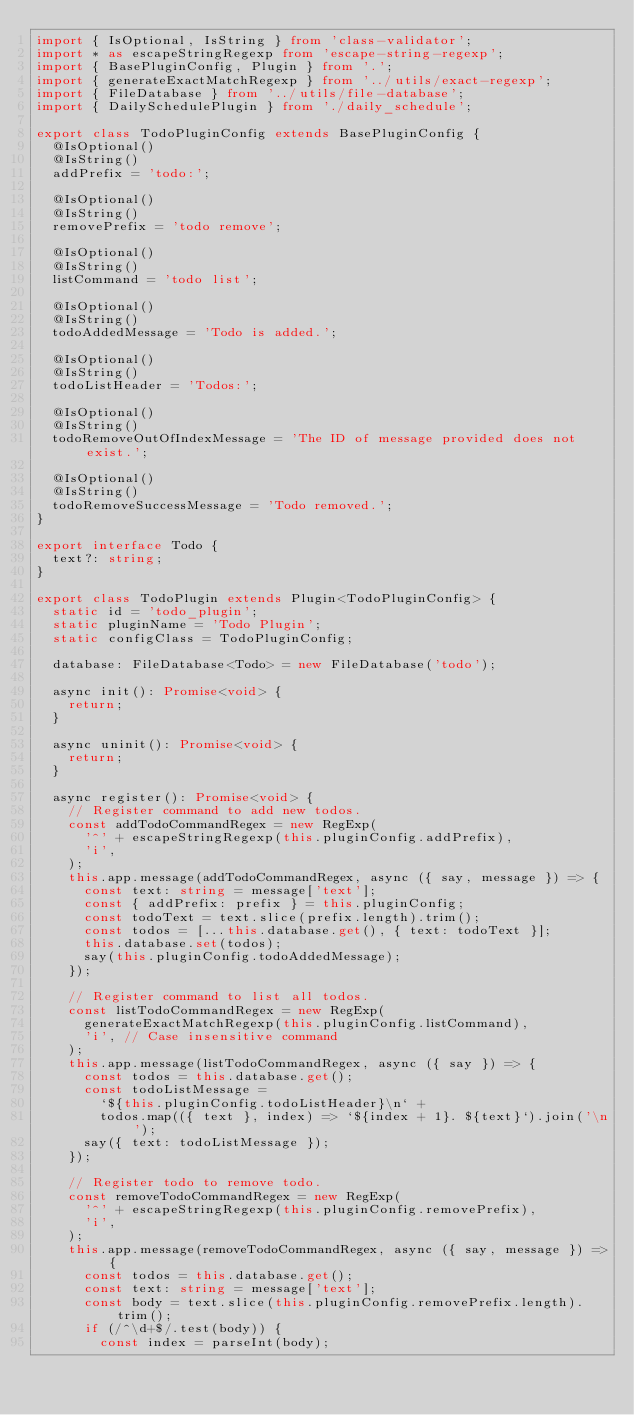Convert code to text. <code><loc_0><loc_0><loc_500><loc_500><_TypeScript_>import { IsOptional, IsString } from 'class-validator';
import * as escapeStringRegexp from 'escape-string-regexp';
import { BasePluginConfig, Plugin } from '.';
import { generateExactMatchRegexp } from '../utils/exact-regexp';
import { FileDatabase } from '../utils/file-database';
import { DailySchedulePlugin } from './daily_schedule';

export class TodoPluginConfig extends BasePluginConfig {
  @IsOptional()
  @IsString()
  addPrefix = 'todo:';

  @IsOptional()
  @IsString()
  removePrefix = 'todo remove';

  @IsOptional()
  @IsString()
  listCommand = 'todo list';

  @IsOptional()
  @IsString()
  todoAddedMessage = 'Todo is added.';

  @IsOptional()
  @IsString()
  todoListHeader = 'Todos:';

  @IsOptional()
  @IsString()
  todoRemoveOutOfIndexMessage = 'The ID of message provided does not exist.';

  @IsOptional()
  @IsString()
  todoRemoveSuccessMessage = 'Todo removed.';
}

export interface Todo {
  text?: string;
}

export class TodoPlugin extends Plugin<TodoPluginConfig> {
  static id = 'todo_plugin';
  static pluginName = 'Todo Plugin';
  static configClass = TodoPluginConfig;

  database: FileDatabase<Todo> = new FileDatabase('todo');

  async init(): Promise<void> {
    return;
  }

  async uninit(): Promise<void> {
    return;
  }

  async register(): Promise<void> {
    // Register command to add new todos.
    const addTodoCommandRegex = new RegExp(
      '^' + escapeStringRegexp(this.pluginConfig.addPrefix),
      'i',
    );
    this.app.message(addTodoCommandRegex, async ({ say, message }) => {
      const text: string = message['text'];
      const { addPrefix: prefix } = this.pluginConfig;
      const todoText = text.slice(prefix.length).trim();
      const todos = [...this.database.get(), { text: todoText }];
      this.database.set(todos);
      say(this.pluginConfig.todoAddedMessage);
    });

    // Register command to list all todos.
    const listTodoCommandRegex = new RegExp(
      generateExactMatchRegexp(this.pluginConfig.listCommand),
      'i', // Case insensitive command
    );
    this.app.message(listTodoCommandRegex, async ({ say }) => {
      const todos = this.database.get();
      const todoListMessage =
        `${this.pluginConfig.todoListHeader}\n` +
        todos.map(({ text }, index) => `${index + 1}. ${text}`).join('\n');
      say({ text: todoListMessage });
    });

    // Register todo to remove todo.
    const removeTodoCommandRegex = new RegExp(
      '^' + escapeStringRegexp(this.pluginConfig.removePrefix),
      'i',
    );
    this.app.message(removeTodoCommandRegex, async ({ say, message }) => {
      const todos = this.database.get();
      const text: string = message['text'];
      const body = text.slice(this.pluginConfig.removePrefix.length).trim();
      if (/^\d+$/.test(body)) {
        const index = parseInt(body);</code> 